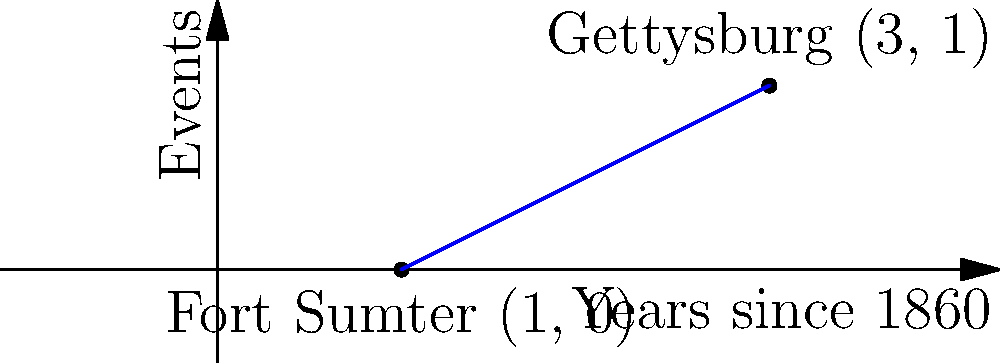On a timeline represented as a coordinate plane, where the x-axis represents years since 1860 and the y-axis represents significant events, Fort Sumter is plotted at (1, 0) and the Battle of Gettysburg at (3, 1). Calculate the slope of the line connecting these two events. What does this slope represent in the context of the Civil War? To find the slope of the line connecting Fort Sumter and the Battle of Gettysburg, we'll use the slope formula:

$$ m = \frac{y_2 - y_1}{x_2 - x_1} $$

Where:
$(x_1, y_1)$ = Fort Sumter (1, 0)
$(x_2, y_2)$ = Battle of Gettysburg (3, 1)

Plugging in the values:

$$ m = \frac{1 - 0}{3 - 1} = \frac{1}{2} = 0.5 $$

The slope is 0.5, which means for every 2 years that pass, we move up 1 unit on the y-axis (events scale).

In the context of the Civil War, this slope represents the rate at which significant events occurred between Fort Sumter (the start of the war in 1861) and the Battle of Gettysburg (a turning point in 1863). The positive slope indicates an escalation or progression of events during this period.
Answer: 0.5; represents rate of significant events occurring between 1861-1863 